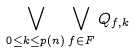<formula> <loc_0><loc_0><loc_500><loc_500>\bigvee _ { 0 \leq k \leq p ( n ) } \bigvee _ { f \in F } Q _ { f , k }</formula> 